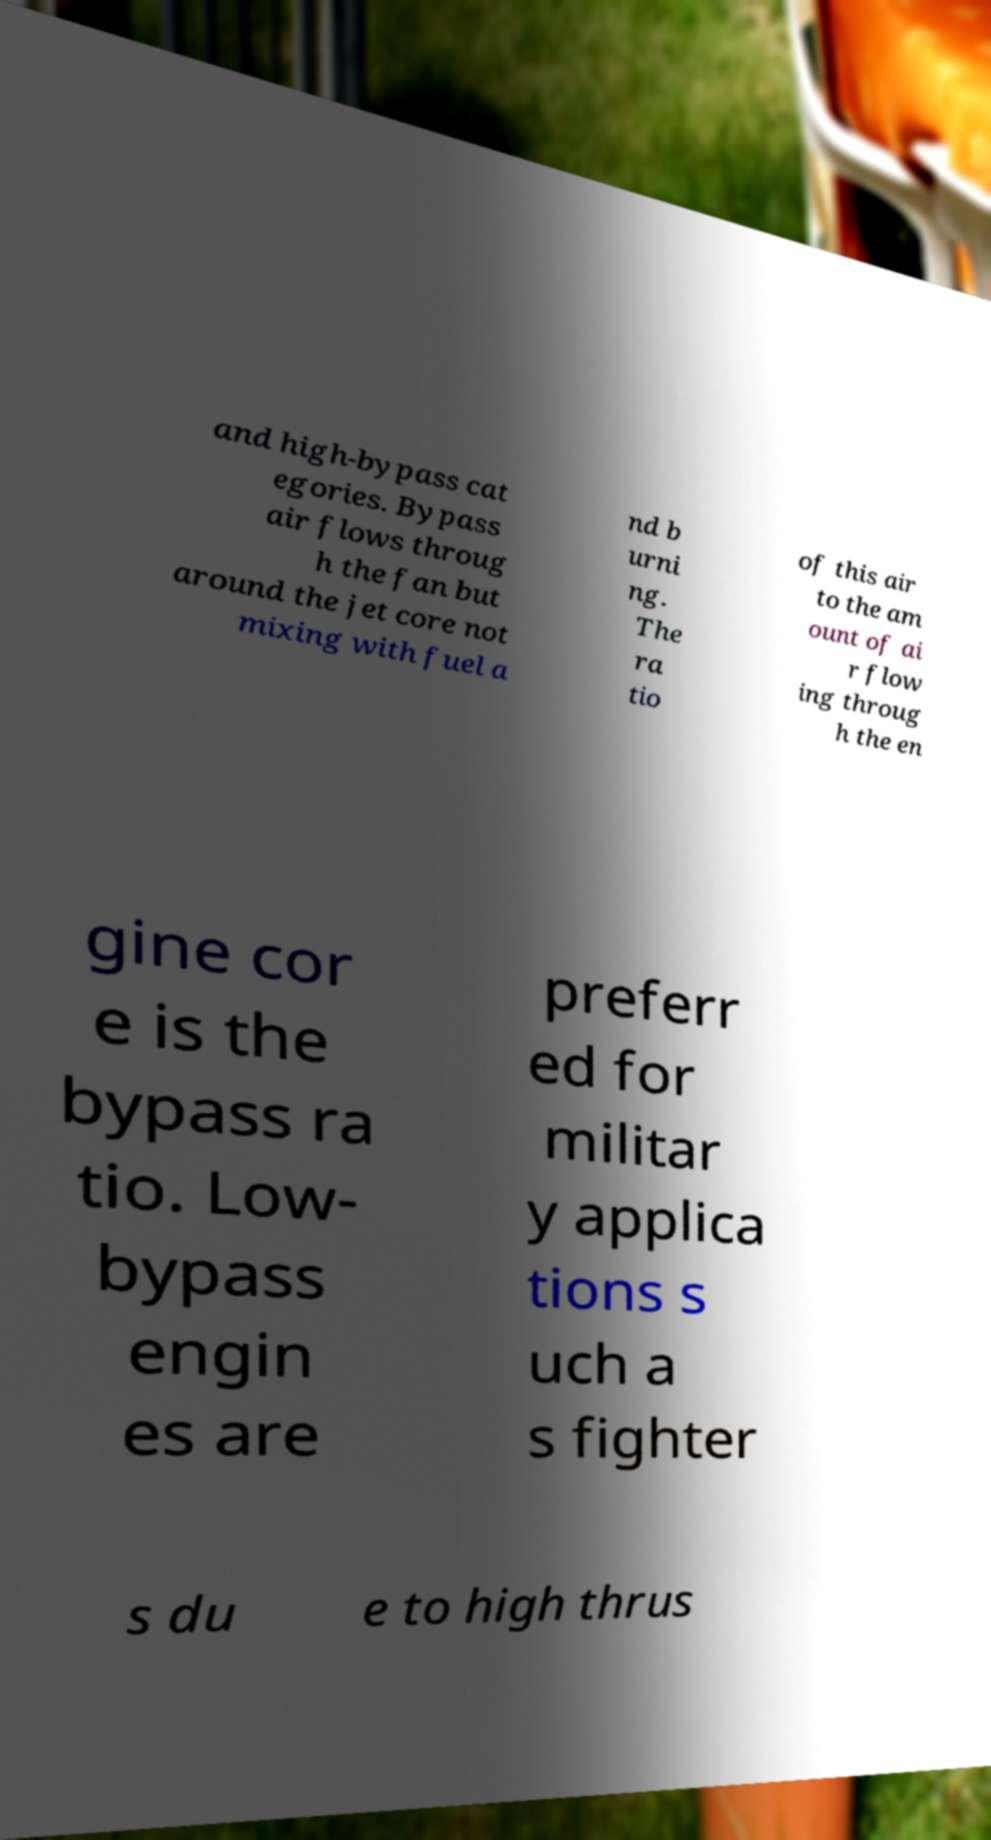For documentation purposes, I need the text within this image transcribed. Could you provide that? and high-bypass cat egories. Bypass air flows throug h the fan but around the jet core not mixing with fuel a nd b urni ng. The ra tio of this air to the am ount of ai r flow ing throug h the en gine cor e is the bypass ra tio. Low- bypass engin es are preferr ed for militar y applica tions s uch a s fighter s du e to high thrus 